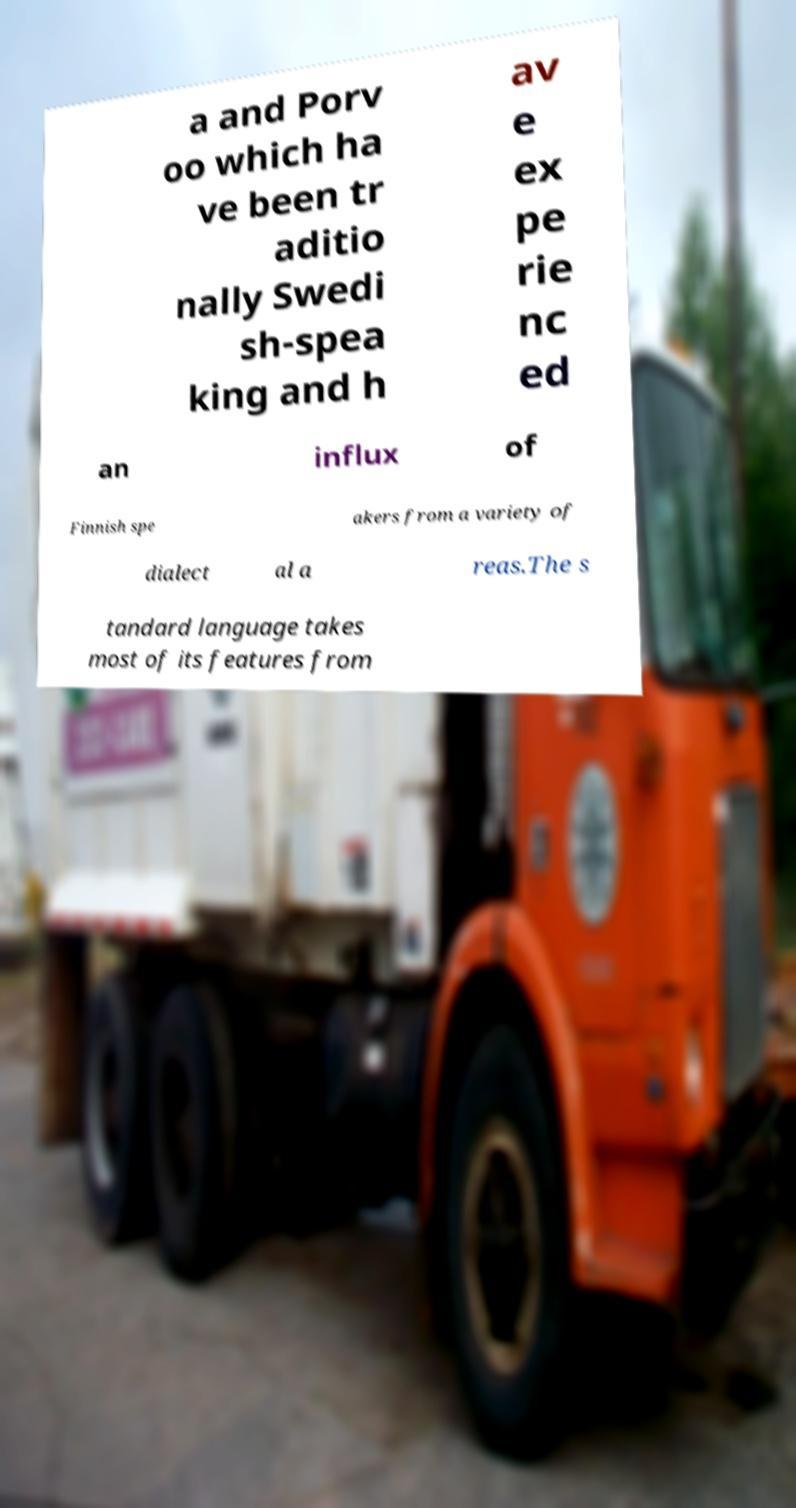What messages or text are displayed in this image? I need them in a readable, typed format. a and Porv oo which ha ve been tr aditio nally Swedi sh-spea king and h av e ex pe rie nc ed an influx of Finnish spe akers from a variety of dialect al a reas.The s tandard language takes most of its features from 